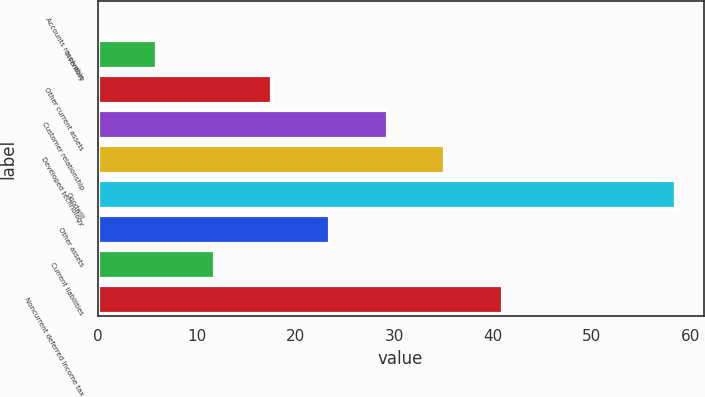<chart> <loc_0><loc_0><loc_500><loc_500><bar_chart><fcel>Accounts receivable<fcel>Inventory<fcel>Other current assets<fcel>Customer relationship<fcel>Developed technology<fcel>Goodwill<fcel>Other assets<fcel>Current liabilities<fcel>Noncurrent deferred income tax<nl><fcel>0.1<fcel>5.93<fcel>17.59<fcel>29.25<fcel>35.08<fcel>58.4<fcel>23.42<fcel>11.76<fcel>40.91<nl></chart> 